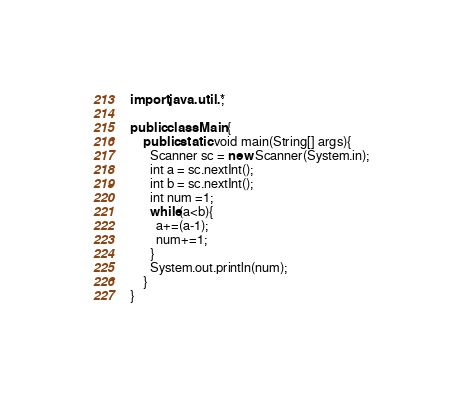Convert code to text. <code><loc_0><loc_0><loc_500><loc_500><_Java_>import java.util.*;

public class Main{
	public static void main(String[] args){
      Scanner sc = new Scanner(System.in);
      int a = sc.nextInt();
      int b = sc.nextInt();
      int num =1;
      while(a<b){
      	a+=(a-1);
        num+=1;
      }
      System.out.println(num);
    }
}</code> 